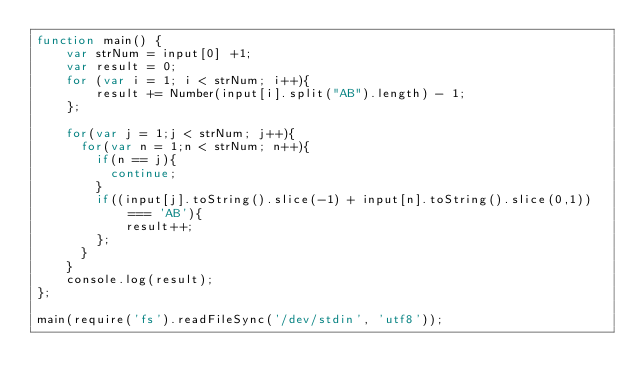Convert code to text. <code><loc_0><loc_0><loc_500><loc_500><_JavaScript_>function main() {
    var strNum = input[0] +1;
    var result = 0;
    for (var i = 1; i < strNum; i++){
        result += Number(input[i].split("AB").length) - 1;
    };
  
  	for(var j = 1;j < strNum; j++){
      for(var n = 1;n < strNum; n++){
        if(n == j){
          continue;
        }        
      	if((input[j].toString().slice(-1) + input[n].toString().slice(0,1)) === 'AB'){
        	result++;
        };
      }
    }
    console.log(result);
};

main(require('fs').readFileSync('/dev/stdin', 'utf8'));</code> 